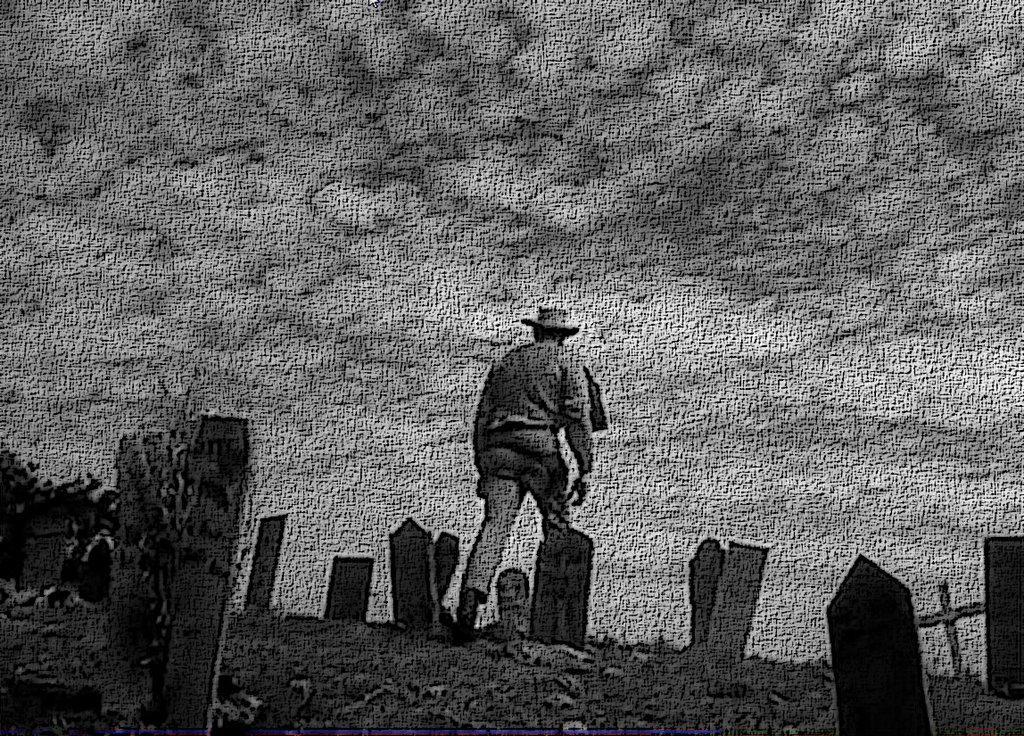Please provide a concise description of this image. This is an edited image. In this image there is a person, memorial stones and sky. 